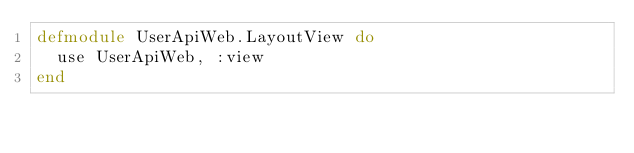<code> <loc_0><loc_0><loc_500><loc_500><_Elixir_>defmodule UserApiWeb.LayoutView do
  use UserApiWeb, :view
end
</code> 